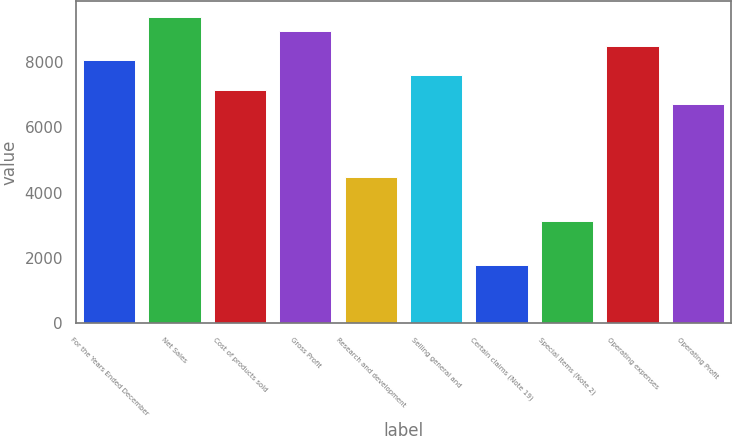Convert chart to OTSL. <chart><loc_0><loc_0><loc_500><loc_500><bar_chart><fcel>For the Years Ended December<fcel>Net Sales<fcel>Cost of products sold<fcel>Gross Profit<fcel>Research and development<fcel>Selling general and<fcel>Certain claims (Note 19)<fcel>Special items (Note 2)<fcel>Operating expenses<fcel>Operating Profit<nl><fcel>8048.7<fcel>9390.06<fcel>7154.46<fcel>8942.94<fcel>4471.74<fcel>7601.58<fcel>1789.02<fcel>3130.38<fcel>8495.82<fcel>6707.34<nl></chart> 